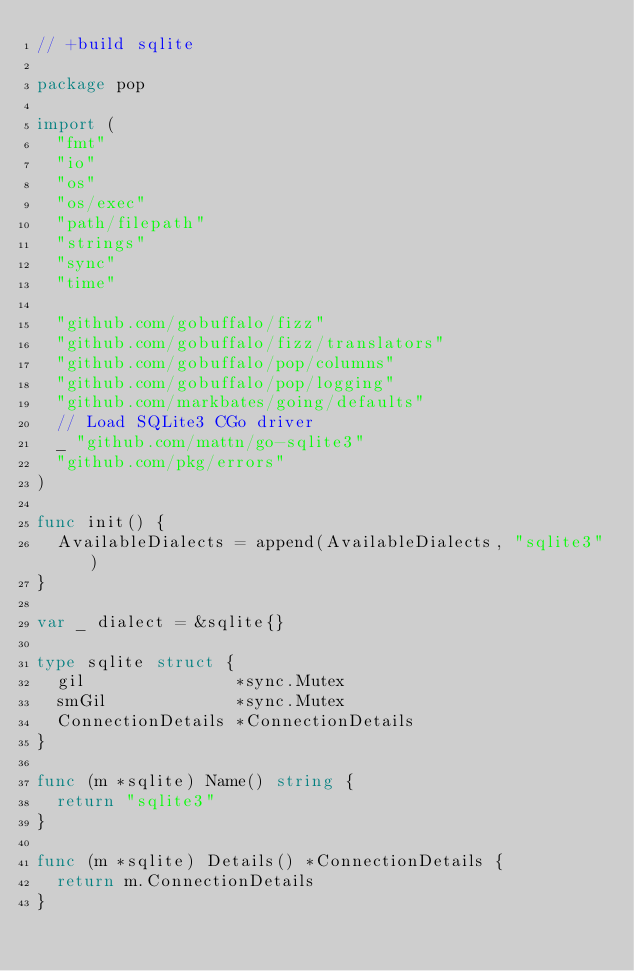<code> <loc_0><loc_0><loc_500><loc_500><_Go_>// +build sqlite

package pop

import (
	"fmt"
	"io"
	"os"
	"os/exec"
	"path/filepath"
	"strings"
	"sync"
	"time"

	"github.com/gobuffalo/fizz"
	"github.com/gobuffalo/fizz/translators"
	"github.com/gobuffalo/pop/columns"
	"github.com/gobuffalo/pop/logging"
	"github.com/markbates/going/defaults"
	// Load SQLite3 CGo driver
	_ "github.com/mattn/go-sqlite3"
	"github.com/pkg/errors"
)

func init() {
	AvailableDialects = append(AvailableDialects, "sqlite3")
}

var _ dialect = &sqlite{}

type sqlite struct {
	gil               *sync.Mutex
	smGil             *sync.Mutex
	ConnectionDetails *ConnectionDetails
}

func (m *sqlite) Name() string {
	return "sqlite3"
}

func (m *sqlite) Details() *ConnectionDetails {
	return m.ConnectionDetails
}
</code> 